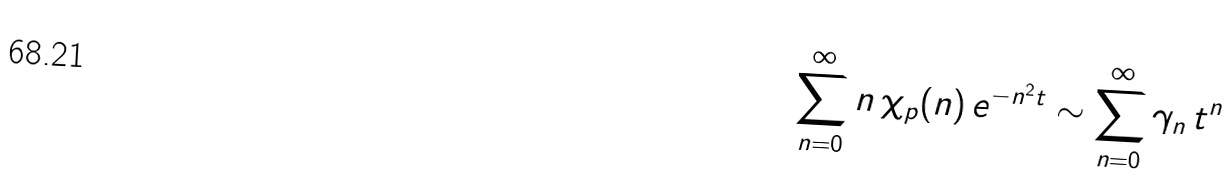Convert formula to latex. <formula><loc_0><loc_0><loc_500><loc_500>\sum _ { n = 0 } ^ { \infty } n \, \chi _ { p } ( n ) \, e ^ { - n ^ { 2 } t } \sim \sum _ { n = 0 } ^ { \infty } \gamma _ { n } \, t ^ { n }</formula> 